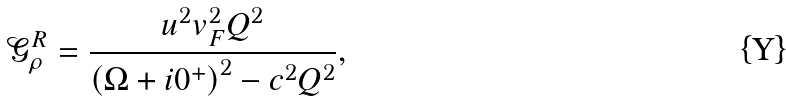Convert formula to latex. <formula><loc_0><loc_0><loc_500><loc_500>\mathcal { G } _ { \rho } ^ { R } = \frac { u ^ { 2 } v _ { F } ^ { 2 } Q ^ { 2 } } { \left ( \Omega + i 0 ^ { + } \right ) ^ { 2 } - c ^ { 2 } Q ^ { 2 } } ,</formula> 